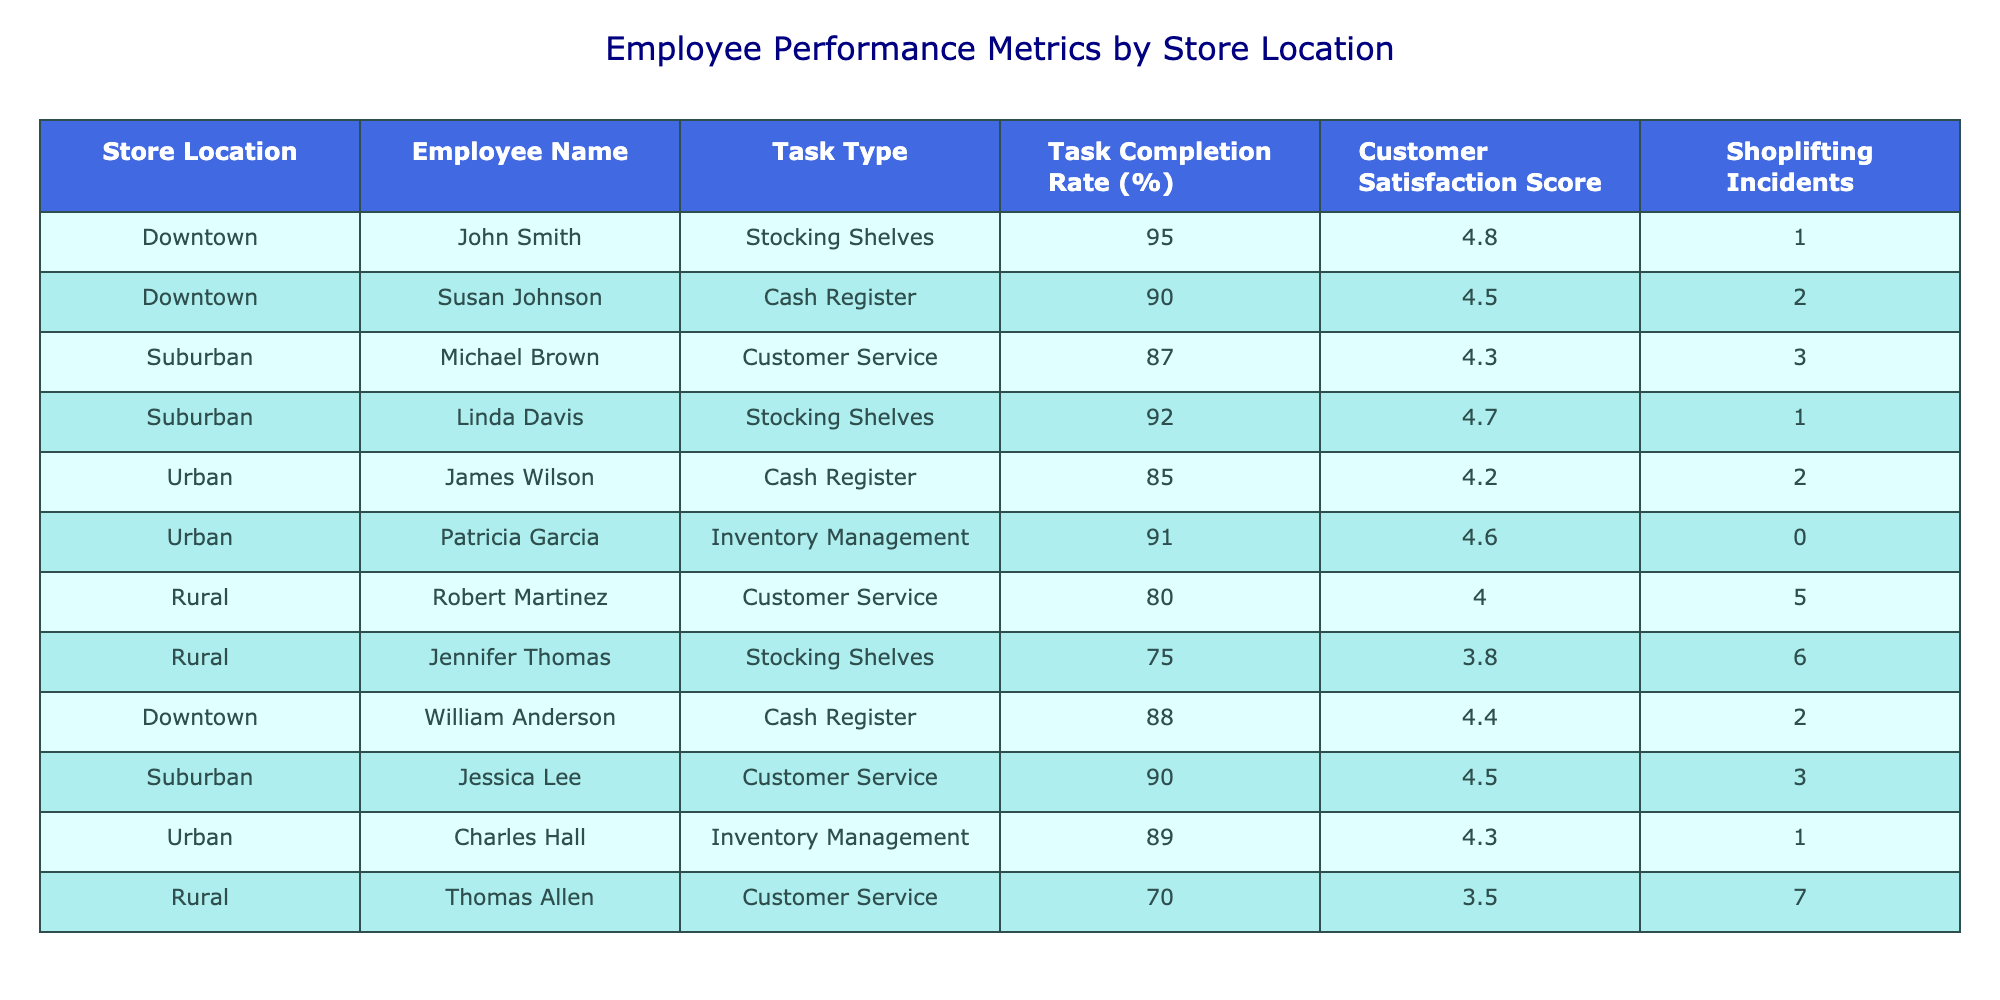What is the highest task completion rate among employees? Referring to the 'Task Completion Rate (%)' column, the highest value is 95, which belongs to John Smith in the Downtown location for the task of Stocking Shelves.
Answer: 95 Which employee received the lowest customer satisfaction score? Looking at the 'Customer Satisfaction Score' column, the lowest score is 3.5, associated with Thomas Allen in the Rural location for the task of Customer Service.
Answer: 3.5 What is the average task completion rate for employees in the Suburban locations? The task completion rates for Suburban employees are 87, 92, and 90. Summing these rates gives 269. Dividing by the number of employees (3) yields an average of 89.67.
Answer: 89.67 Did any employee in the Urban location achieve a task completion rate above 90? Checking the 'Task Completion Rate (%)' for Urban employees, Patricia Garcia has a rate of 91, which is above 90.
Answer: Yes How many shoplifting incidents were reported in total across all locations? Adding the 'Shoplifting Incidents' from each store yields a total of 1 + 2 + 3 + 1 + 2 + 0 + 5 + 6 + 2 + 3 + 1 + 7 = 30 incidents.
Answer: 30 Which store location had the highest customer satisfaction score among its employees? From the 'Customer Satisfaction Score' column, the highest score is 4.8 from John Smith in Downtown. Since Downtown also has comparable scores, it indicates that Downtown consistently achieves high satisfaction.
Answer: Downtown What is the difference in task completion rate between the best and the worst performing employee? The best completion rate is 95 (John Smith), while the worst is 70 (Thomas Allen). The difference calculated is 95 - 70 = 25.
Answer: 25 Is there any employee who has a customer satisfaction score of 4.5 or higher and a task completion rate of 90% or more? John Smith (4.8 and 95), Susan Johnson (4.5 and 90), and Linda Davis (4.7 and 92) meet both criteria. Thus, yes, there are multiple employees fulfilling these conditions.
Answer: Yes 